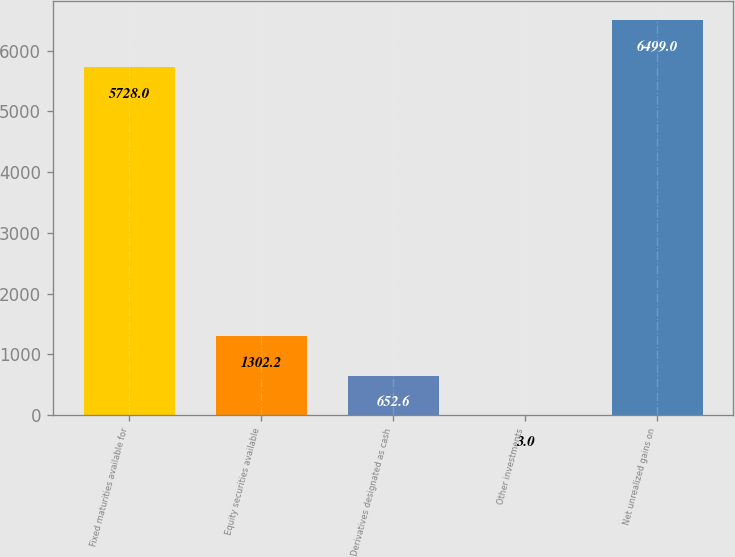Convert chart to OTSL. <chart><loc_0><loc_0><loc_500><loc_500><bar_chart><fcel>Fixed maturities available for<fcel>Equity securities available<fcel>Derivatives designated as cash<fcel>Other investments<fcel>Net unrealized gains on<nl><fcel>5728<fcel>1302.2<fcel>652.6<fcel>3<fcel>6499<nl></chart> 